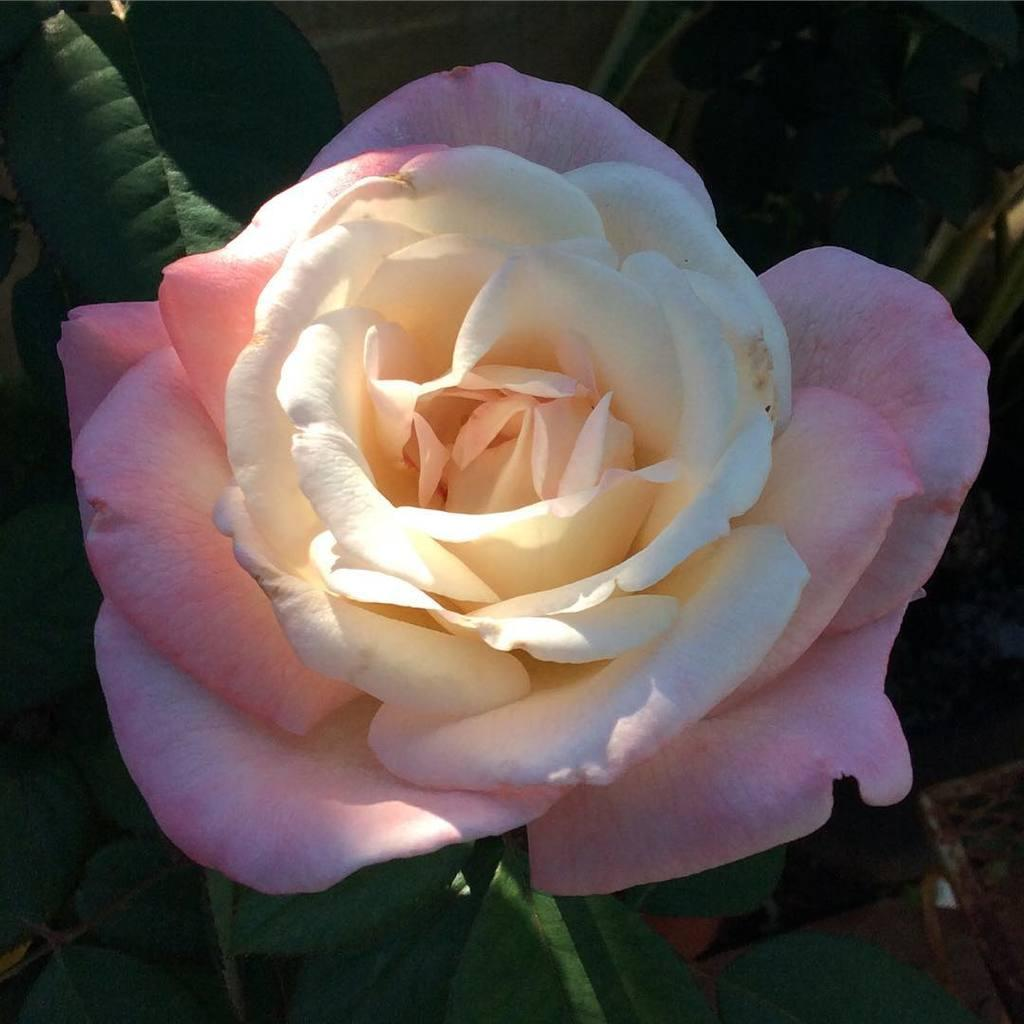What type of plant can be seen in the image? There is a flower plant in the image. What relation does the flower plant have with the destruction of the building in the image? There is no building or destruction present in the image; it only features a flower plant. 